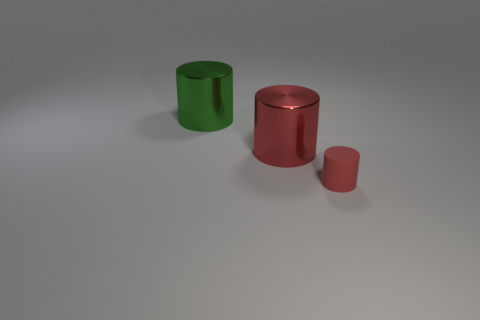Add 2 metallic things. How many objects exist? 5 Subtract 0 yellow spheres. How many objects are left? 3 Subtract all large cylinders. Subtract all tiny yellow rubber cubes. How many objects are left? 1 Add 2 cylinders. How many cylinders are left? 5 Add 3 small purple cylinders. How many small purple cylinders exist? 3 